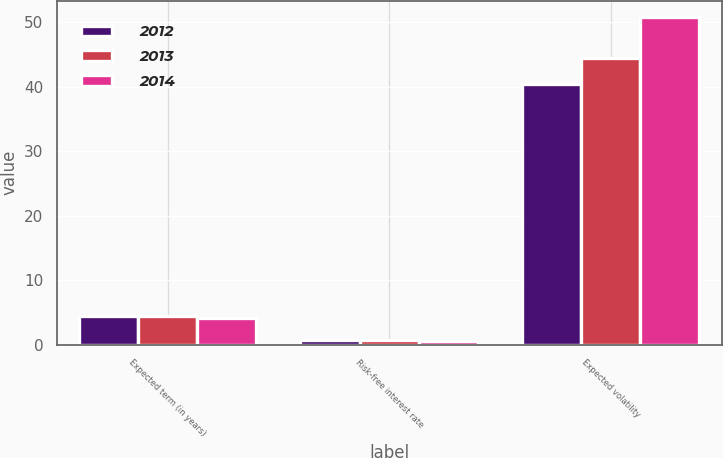Convert chart to OTSL. <chart><loc_0><loc_0><loc_500><loc_500><stacked_bar_chart><ecel><fcel>Expected term (in years)<fcel>Risk-free interest rate<fcel>Expected volatility<nl><fcel>2012<fcel>4.4<fcel>0.8<fcel>40.4<nl><fcel>2013<fcel>4.5<fcel>0.8<fcel>44.4<nl><fcel>2014<fcel>4.2<fcel>0.6<fcel>50.8<nl></chart> 